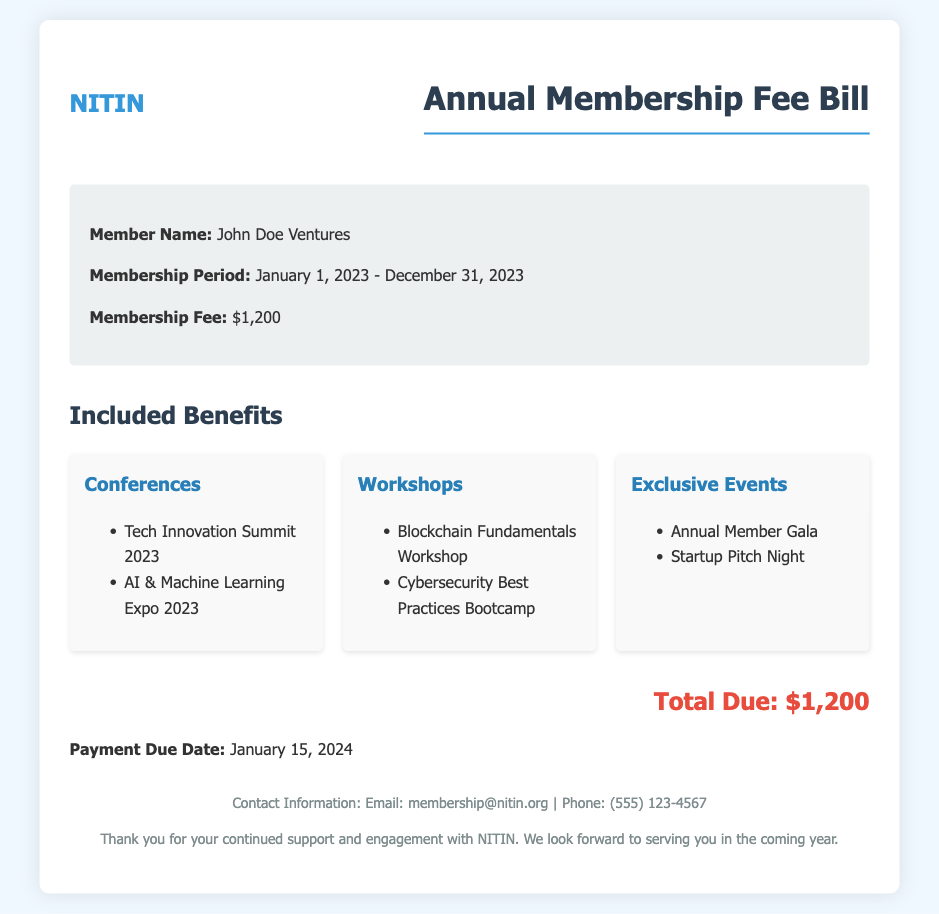What is the member name? The member name is listed under the bill information section.
Answer: John Doe Ventures What is the membership fee? The membership fee is explicitly stated in the bill information section.
Answer: $1,200 What is the membership period? The membership period clarifies the duration of the membership, indicated in the bill.
Answer: January 1, 2023 - December 31, 2023 What is the payment due date? The payment due date is mentioned in the document towards the end.
Answer: January 15, 2024 Which conference was included in the benefits? The included benefits section lists the conferences available to the member.
Answer: Tech Innovation Summit 2023 How many workshops are listed in the document? The document explicitly lists the workshops under the benefits section.
Answer: 2 What type of event is the "Annual Member Gala"? This event is categorized under exclusive events within the benefits section of the document.
Answer: Exclusive Event What is the total due amount? The total due amount is clearly stated in the document.
Answer: $1,200 